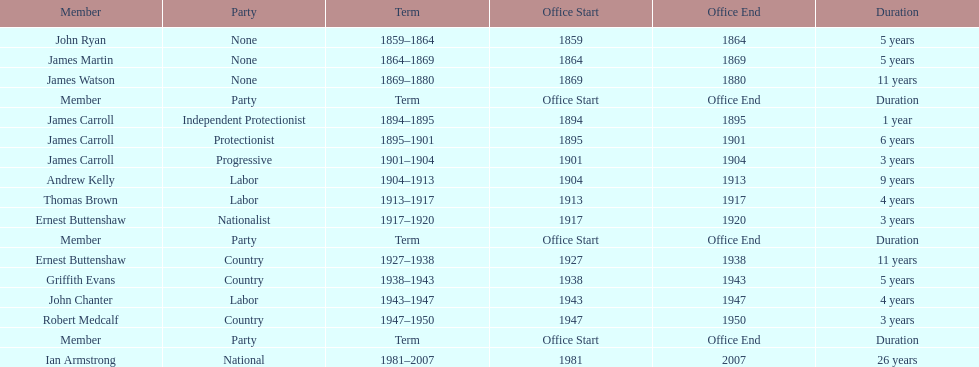Parse the full table. {'header': ['Member', 'Party', 'Term', 'Office Start', 'Office End', 'Duration'], 'rows': [['John Ryan', 'None', '1859–1864', '1859', '1864', '5 years'], ['James Martin', 'None', '1864–1869', '1864', '1869', '5 years'], ['James Watson', 'None', '1869–1880', '1869', '1880', '11 years'], ['Member', 'Party', 'Term', 'Office Start', 'Office End', 'Duration'], ['James Carroll', 'Independent Protectionist', '1894–1895', '1894', '1895', '1 year'], ['James Carroll', 'Protectionist', '1895–1901', '1895', '1901', '6 years'], ['James Carroll', 'Progressive', '1901–1904', '1901', '1904', '3 years'], ['Andrew Kelly', 'Labor', '1904–1913', '1904', '1913', '9 years'], ['Thomas Brown', 'Labor', '1913–1917', '1913', '1917', '4 years'], ['Ernest Buttenshaw', 'Nationalist', '1917–1920', '1917', '1920', '3 years'], ['Member', 'Party', 'Term', 'Office Start', 'Office End', 'Duration'], ['Ernest Buttenshaw', 'Country', '1927–1938', '1927', '1938', '11 years'], ['Griffith Evans', 'Country', '1938–1943', '1938', '1943', '5 years'], ['John Chanter', 'Labor', '1943–1947', '1943', '1947', '4 years'], ['Robert Medcalf', 'Country', '1947–1950', '1947', '1950', '3 years'], ['Member', 'Party', 'Term', 'Office Start', 'Office End', 'Duration'], ['Ian Armstrong', 'National', '1981–2007', '1981', '2007', '26 years']]} How long did the fourth incarnation of the lachlan exist? 1981-2007. 